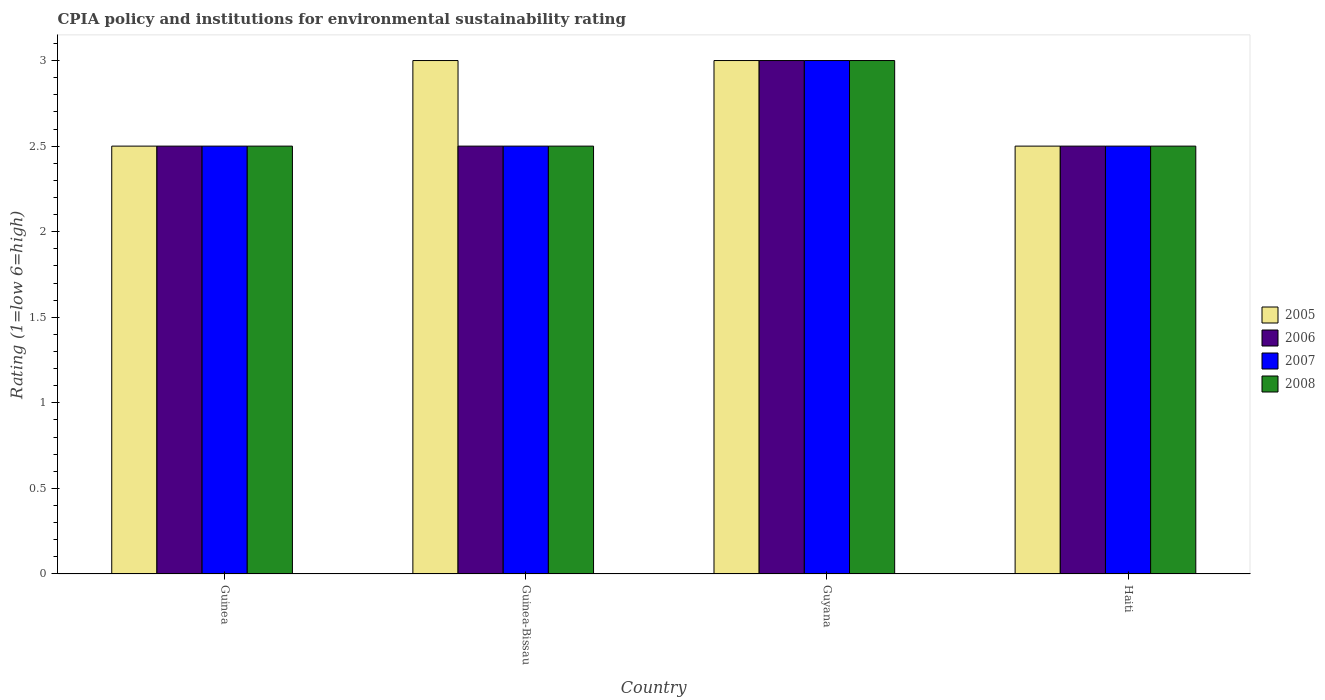How many different coloured bars are there?
Provide a short and direct response. 4. How many groups of bars are there?
Keep it short and to the point. 4. Are the number of bars on each tick of the X-axis equal?
Keep it short and to the point. Yes. How many bars are there on the 3rd tick from the left?
Make the answer very short. 4. What is the label of the 4th group of bars from the left?
Offer a terse response. Haiti. In how many cases, is the number of bars for a given country not equal to the number of legend labels?
Offer a terse response. 0. In which country was the CPIA rating in 2007 maximum?
Your answer should be very brief. Guyana. In which country was the CPIA rating in 2008 minimum?
Offer a very short reply. Guinea. What is the total CPIA rating in 2005 in the graph?
Give a very brief answer. 11. What is the difference between the CPIA rating in 2006 in Haiti and the CPIA rating in 2008 in Guyana?
Your response must be concise. -0.5. What is the average CPIA rating in 2006 per country?
Provide a short and direct response. 2.62. What is the ratio of the CPIA rating in 2008 in Guinea-Bissau to that in Haiti?
Your response must be concise. 1. Is the CPIA rating in 2006 in Guinea less than that in Haiti?
Offer a terse response. No. Is the difference between the CPIA rating in 2006 in Guinea and Haiti greater than the difference between the CPIA rating in 2005 in Guinea and Haiti?
Give a very brief answer. No. Is the sum of the CPIA rating in 2005 in Guyana and Haiti greater than the maximum CPIA rating in 2008 across all countries?
Keep it short and to the point. Yes. Is it the case that in every country, the sum of the CPIA rating in 2005 and CPIA rating in 2006 is greater than the sum of CPIA rating in 2008 and CPIA rating in 2007?
Ensure brevity in your answer.  No. What does the 2nd bar from the right in Guyana represents?
Ensure brevity in your answer.  2007. Are all the bars in the graph horizontal?
Your answer should be very brief. No. How many countries are there in the graph?
Ensure brevity in your answer.  4. Are the values on the major ticks of Y-axis written in scientific E-notation?
Provide a short and direct response. No. Does the graph contain any zero values?
Your answer should be very brief. No. Does the graph contain grids?
Offer a terse response. No. What is the title of the graph?
Provide a succinct answer. CPIA policy and institutions for environmental sustainability rating. What is the label or title of the Y-axis?
Your answer should be very brief. Rating (1=low 6=high). What is the Rating (1=low 6=high) of 2008 in Guinea?
Provide a succinct answer. 2.5. What is the Rating (1=low 6=high) of 2005 in Guinea-Bissau?
Provide a succinct answer. 3. What is the Rating (1=low 6=high) in 2007 in Guinea-Bissau?
Your answer should be very brief. 2.5. What is the Rating (1=low 6=high) in 2008 in Guyana?
Provide a short and direct response. 3. What is the Rating (1=low 6=high) in 2005 in Haiti?
Your response must be concise. 2.5. What is the Rating (1=low 6=high) of 2008 in Haiti?
Your answer should be compact. 2.5. Across all countries, what is the maximum Rating (1=low 6=high) in 2005?
Your answer should be compact. 3. Across all countries, what is the maximum Rating (1=low 6=high) of 2006?
Your answer should be very brief. 3. Across all countries, what is the maximum Rating (1=low 6=high) in 2007?
Give a very brief answer. 3. Across all countries, what is the maximum Rating (1=low 6=high) of 2008?
Give a very brief answer. 3. Across all countries, what is the minimum Rating (1=low 6=high) in 2006?
Give a very brief answer. 2.5. Across all countries, what is the minimum Rating (1=low 6=high) in 2008?
Your answer should be very brief. 2.5. What is the total Rating (1=low 6=high) in 2005 in the graph?
Ensure brevity in your answer.  11. What is the total Rating (1=low 6=high) in 2006 in the graph?
Provide a short and direct response. 10.5. What is the total Rating (1=low 6=high) of 2008 in the graph?
Provide a succinct answer. 10.5. What is the difference between the Rating (1=low 6=high) in 2005 in Guinea and that in Guinea-Bissau?
Offer a very short reply. -0.5. What is the difference between the Rating (1=low 6=high) of 2006 in Guinea and that in Guinea-Bissau?
Provide a succinct answer. 0. What is the difference between the Rating (1=low 6=high) of 2007 in Guinea and that in Guinea-Bissau?
Your answer should be compact. 0. What is the difference between the Rating (1=low 6=high) in 2005 in Guinea and that in Guyana?
Your answer should be compact. -0.5. What is the difference between the Rating (1=low 6=high) in 2006 in Guinea and that in Guyana?
Your answer should be compact. -0.5. What is the difference between the Rating (1=low 6=high) of 2007 in Guinea and that in Guyana?
Your response must be concise. -0.5. What is the difference between the Rating (1=low 6=high) of 2008 in Guinea and that in Guyana?
Your response must be concise. -0.5. What is the difference between the Rating (1=low 6=high) of 2006 in Guinea and that in Haiti?
Your response must be concise. 0. What is the difference between the Rating (1=low 6=high) in 2006 in Guinea-Bissau and that in Guyana?
Ensure brevity in your answer.  -0.5. What is the difference between the Rating (1=low 6=high) in 2007 in Guinea-Bissau and that in Guyana?
Your response must be concise. -0.5. What is the difference between the Rating (1=low 6=high) in 2006 in Guinea-Bissau and that in Haiti?
Offer a terse response. 0. What is the difference between the Rating (1=low 6=high) in 2008 in Guinea-Bissau and that in Haiti?
Make the answer very short. 0. What is the difference between the Rating (1=low 6=high) of 2006 in Guyana and that in Haiti?
Your answer should be compact. 0.5. What is the difference between the Rating (1=low 6=high) in 2007 in Guyana and that in Haiti?
Offer a very short reply. 0.5. What is the difference between the Rating (1=low 6=high) of 2005 in Guinea and the Rating (1=low 6=high) of 2008 in Guinea-Bissau?
Keep it short and to the point. 0. What is the difference between the Rating (1=low 6=high) in 2006 in Guinea and the Rating (1=low 6=high) in 2007 in Guinea-Bissau?
Give a very brief answer. 0. What is the difference between the Rating (1=low 6=high) in 2006 in Guinea and the Rating (1=low 6=high) in 2008 in Guinea-Bissau?
Keep it short and to the point. 0. What is the difference between the Rating (1=low 6=high) in 2007 in Guinea and the Rating (1=low 6=high) in 2008 in Guinea-Bissau?
Provide a short and direct response. 0. What is the difference between the Rating (1=low 6=high) in 2005 in Guinea and the Rating (1=low 6=high) in 2006 in Guyana?
Provide a succinct answer. -0.5. What is the difference between the Rating (1=low 6=high) in 2005 in Guinea and the Rating (1=low 6=high) in 2007 in Guyana?
Give a very brief answer. -0.5. What is the difference between the Rating (1=low 6=high) of 2005 in Guinea and the Rating (1=low 6=high) of 2008 in Guyana?
Ensure brevity in your answer.  -0.5. What is the difference between the Rating (1=low 6=high) of 2005 in Guinea and the Rating (1=low 6=high) of 2006 in Haiti?
Provide a short and direct response. 0. What is the difference between the Rating (1=low 6=high) of 2006 in Guinea and the Rating (1=low 6=high) of 2008 in Haiti?
Your response must be concise. 0. What is the difference between the Rating (1=low 6=high) in 2005 in Guinea-Bissau and the Rating (1=low 6=high) in 2006 in Guyana?
Provide a succinct answer. 0. What is the difference between the Rating (1=low 6=high) in 2005 in Guinea-Bissau and the Rating (1=low 6=high) in 2007 in Guyana?
Provide a short and direct response. 0. What is the difference between the Rating (1=low 6=high) in 2007 in Guinea-Bissau and the Rating (1=low 6=high) in 2008 in Guyana?
Ensure brevity in your answer.  -0.5. What is the difference between the Rating (1=low 6=high) in 2005 in Guinea-Bissau and the Rating (1=low 6=high) in 2006 in Haiti?
Provide a short and direct response. 0.5. What is the difference between the Rating (1=low 6=high) in 2005 in Guinea-Bissau and the Rating (1=low 6=high) in 2008 in Haiti?
Keep it short and to the point. 0.5. What is the difference between the Rating (1=low 6=high) in 2006 in Guinea-Bissau and the Rating (1=low 6=high) in 2007 in Haiti?
Ensure brevity in your answer.  0. What is the difference between the Rating (1=low 6=high) of 2006 in Guinea-Bissau and the Rating (1=low 6=high) of 2008 in Haiti?
Provide a succinct answer. 0. What is the difference between the Rating (1=low 6=high) of 2006 in Guyana and the Rating (1=low 6=high) of 2008 in Haiti?
Your answer should be very brief. 0.5. What is the difference between the Rating (1=low 6=high) of 2007 in Guyana and the Rating (1=low 6=high) of 2008 in Haiti?
Provide a short and direct response. 0.5. What is the average Rating (1=low 6=high) in 2005 per country?
Your response must be concise. 2.75. What is the average Rating (1=low 6=high) in 2006 per country?
Offer a terse response. 2.62. What is the average Rating (1=low 6=high) of 2007 per country?
Provide a short and direct response. 2.62. What is the average Rating (1=low 6=high) of 2008 per country?
Provide a succinct answer. 2.62. What is the difference between the Rating (1=low 6=high) in 2005 and Rating (1=low 6=high) in 2006 in Guinea?
Your response must be concise. 0. What is the difference between the Rating (1=low 6=high) in 2005 and Rating (1=low 6=high) in 2007 in Guinea?
Make the answer very short. 0. What is the difference between the Rating (1=low 6=high) of 2007 and Rating (1=low 6=high) of 2008 in Guinea?
Offer a terse response. 0. What is the difference between the Rating (1=low 6=high) of 2006 and Rating (1=low 6=high) of 2007 in Guinea-Bissau?
Ensure brevity in your answer.  0. What is the difference between the Rating (1=low 6=high) of 2005 and Rating (1=low 6=high) of 2007 in Guyana?
Your answer should be very brief. 0. What is the difference between the Rating (1=low 6=high) in 2006 and Rating (1=low 6=high) in 2007 in Guyana?
Make the answer very short. 0. What is the difference between the Rating (1=low 6=high) of 2006 and Rating (1=low 6=high) of 2008 in Guyana?
Offer a very short reply. 0. What is the difference between the Rating (1=low 6=high) in 2007 and Rating (1=low 6=high) in 2008 in Guyana?
Your answer should be very brief. 0. What is the difference between the Rating (1=low 6=high) of 2005 and Rating (1=low 6=high) of 2007 in Haiti?
Provide a succinct answer. 0. What is the difference between the Rating (1=low 6=high) in 2006 and Rating (1=low 6=high) in 2008 in Haiti?
Ensure brevity in your answer.  0. What is the difference between the Rating (1=low 6=high) of 2007 and Rating (1=low 6=high) of 2008 in Haiti?
Provide a succinct answer. 0. What is the ratio of the Rating (1=low 6=high) of 2006 in Guinea to that in Guinea-Bissau?
Make the answer very short. 1. What is the ratio of the Rating (1=low 6=high) of 2006 in Guinea to that in Guyana?
Provide a succinct answer. 0.83. What is the ratio of the Rating (1=low 6=high) in 2008 in Guinea to that in Guyana?
Your answer should be very brief. 0.83. What is the ratio of the Rating (1=low 6=high) of 2006 in Guinea to that in Haiti?
Provide a short and direct response. 1. What is the ratio of the Rating (1=low 6=high) of 2007 in Guinea to that in Haiti?
Offer a very short reply. 1. What is the ratio of the Rating (1=low 6=high) of 2006 in Guinea-Bissau to that in Guyana?
Give a very brief answer. 0.83. What is the ratio of the Rating (1=low 6=high) of 2007 in Guinea-Bissau to that in Guyana?
Your answer should be very brief. 0.83. What is the ratio of the Rating (1=low 6=high) in 2005 in Guyana to that in Haiti?
Your answer should be very brief. 1.2. What is the difference between the highest and the second highest Rating (1=low 6=high) in 2005?
Ensure brevity in your answer.  0. What is the difference between the highest and the second highest Rating (1=low 6=high) in 2007?
Keep it short and to the point. 0.5. What is the difference between the highest and the second highest Rating (1=low 6=high) in 2008?
Provide a succinct answer. 0.5. What is the difference between the highest and the lowest Rating (1=low 6=high) of 2007?
Keep it short and to the point. 0.5. 